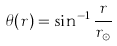Convert formula to latex. <formula><loc_0><loc_0><loc_500><loc_500>\theta ( r ) = \sin ^ { - 1 } \frac { r } { r _ { \odot } }</formula> 